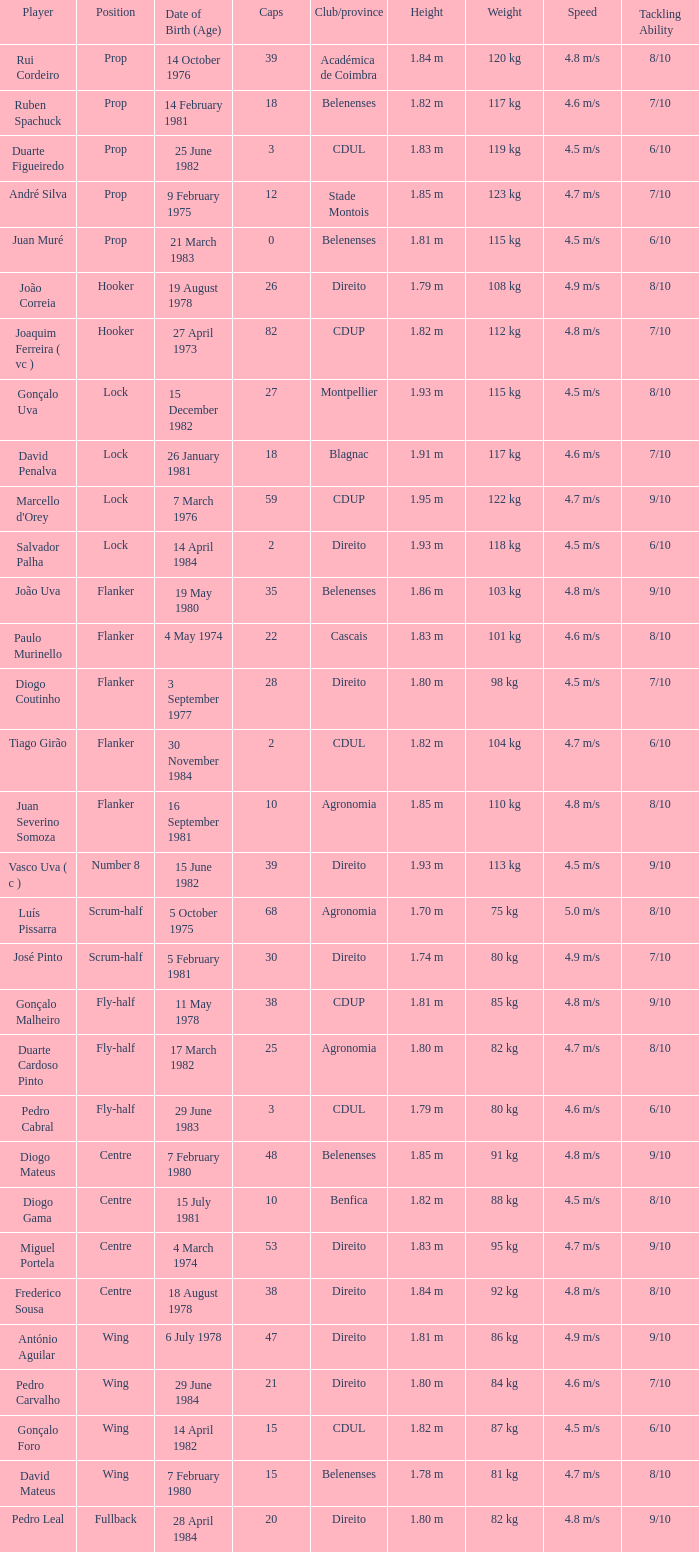How many caps have a Position of prop, and a Player of rui cordeiro? 1.0. Parse the full table. {'header': ['Player', 'Position', 'Date of Birth (Age)', 'Caps', 'Club/province', 'Height', 'Weight', 'Speed', 'Tackling Ability'], 'rows': [['Rui Cordeiro', 'Prop', '14 October 1976', '39', 'Académica de Coimbra', '1.84 m', '120 kg', '4.8 m/s', '8/10'], ['Ruben Spachuck', 'Prop', '14 February 1981', '18', 'Belenenses', '1.82 m', '117 kg', '4.6 m/s', '7/10'], ['Duarte Figueiredo', 'Prop', '25 June 1982', '3', 'CDUL', '1.83 m', '119 kg', '4.5 m/s', '6/10'], ['André Silva', 'Prop', '9 February 1975', '12', 'Stade Montois', '1.85 m', '123 kg', '4.7 m/s', '7/10'], ['Juan Muré', 'Prop', '21 March 1983', '0', 'Belenenses', '1.81 m', '115 kg', '4.5 m/s', '6/10'], ['João Correia', 'Hooker', '19 August 1978', '26', 'Direito', '1.79 m', '108 kg', '4.9 m/s', '8/10'], ['Joaquim Ferreira ( vc )', 'Hooker', '27 April 1973', '82', 'CDUP', '1.82 m', '112 kg', '4.8 m/s', '7/10'], ['Gonçalo Uva', 'Lock', '15 December 1982', '27', 'Montpellier', '1.93 m', '115 kg', '4.5 m/s', '8/10'], ['David Penalva', 'Lock', '26 January 1981', '18', 'Blagnac', '1.91 m', '117 kg', '4.6 m/s', '7/10'], ["Marcello d'Orey", 'Lock', '7 March 1976', '59', 'CDUP', '1.95 m', '122 kg', '4.7 m/s', '9/10'], ['Salvador Palha', 'Lock', '14 April 1984', '2', 'Direito', '1.93 m', '118 kg', '4.5 m/s', '6/10'], ['João Uva', 'Flanker', '19 May 1980', '35', 'Belenenses', '1.86 m', '103 kg', '4.8 m/s', '9/10'], ['Paulo Murinello', 'Flanker', '4 May 1974', '22', 'Cascais', '1.83 m', '101 kg', '4.6 m/s', '8/10'], ['Diogo Coutinho', 'Flanker', '3 September 1977', '28', 'Direito', '1.80 m', '98 kg', '4.5 m/s', '7/10'], ['Tiago Girão', 'Flanker', '30 November 1984', '2', 'CDUL', '1.82 m', '104 kg', '4.7 m/s', '6/10'], ['Juan Severino Somoza', 'Flanker', '16 September 1981', '10', 'Agronomia', '1.85 m', '110 kg', '4.8 m/s', '8/10'], ['Vasco Uva ( c )', 'Number 8', '15 June 1982', '39', 'Direito', '1.93 m', '113 kg', '4.5 m/s', '9/10'], ['Luís Pissarra', 'Scrum-half', '5 October 1975', '68', 'Agronomia', '1.70 m', '75 kg', '5.0 m/s', '8/10'], ['José Pinto', 'Scrum-half', '5 February 1981', '30', 'Direito', '1.74 m', '80 kg', '4.9 m/s', '7/10'], ['Gonçalo Malheiro', 'Fly-half', '11 May 1978', '38', 'CDUP', '1.81 m', '85 kg', '4.8 m/s', '9/10'], ['Duarte Cardoso Pinto', 'Fly-half', '17 March 1982', '25', 'Agronomia', '1.80 m', '82 kg', '4.7 m/s', '8/10'], ['Pedro Cabral', 'Fly-half', '29 June 1983', '3', 'CDUL', '1.79 m', '80 kg', '4.6 m/s', '6/10'], ['Diogo Mateus', 'Centre', '7 February 1980', '48', 'Belenenses', '1.85 m', '91 kg', '4.8 m/s', '9/10'], ['Diogo Gama', 'Centre', '15 July 1981', '10', 'Benfica', '1.82 m', '88 kg', '4.5 m/s', '8/10'], ['Miguel Portela', 'Centre', '4 March 1974', '53', 'Direito', '1.83 m', '95 kg', '4.7 m/s', '9/10'], ['Frederico Sousa', 'Centre', '18 August 1978', '38', 'Direito', '1.84 m', '92 kg', '4.8 m/s', '8/10'], ['António Aguilar', 'Wing', '6 July 1978', '47', 'Direito', '1.81 m', '86 kg', '4.9 m/s', '9/10'], ['Pedro Carvalho', 'Wing', '29 June 1984', '21', 'Direito', '1.80 m', '84 kg', '4.6 m/s', '7/10'], ['Gonçalo Foro', 'Wing', '14 April 1982', '15', 'CDUL', '1.82 m', '87 kg', '4.5 m/s', '6/10'], ['David Mateus', 'Wing', '7 February 1980', '15', 'Belenenses', '1.78 m', '81 kg', '4.7 m/s', '8/10'], ['Pedro Leal', 'Fullback', '28 April 1984', '20', 'Direito', '1.80 m', '82 kg', '4.8 m/s', '9/10']]} 